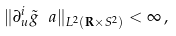<formula> <loc_0><loc_0><loc_500><loc_500>\| \partial _ { u } ^ { i } \tilde { g } _ { \ } a \| _ { L ^ { 2 } ( { \mathbf R } \times S ^ { 2 } ) } < \infty \, ,</formula> 